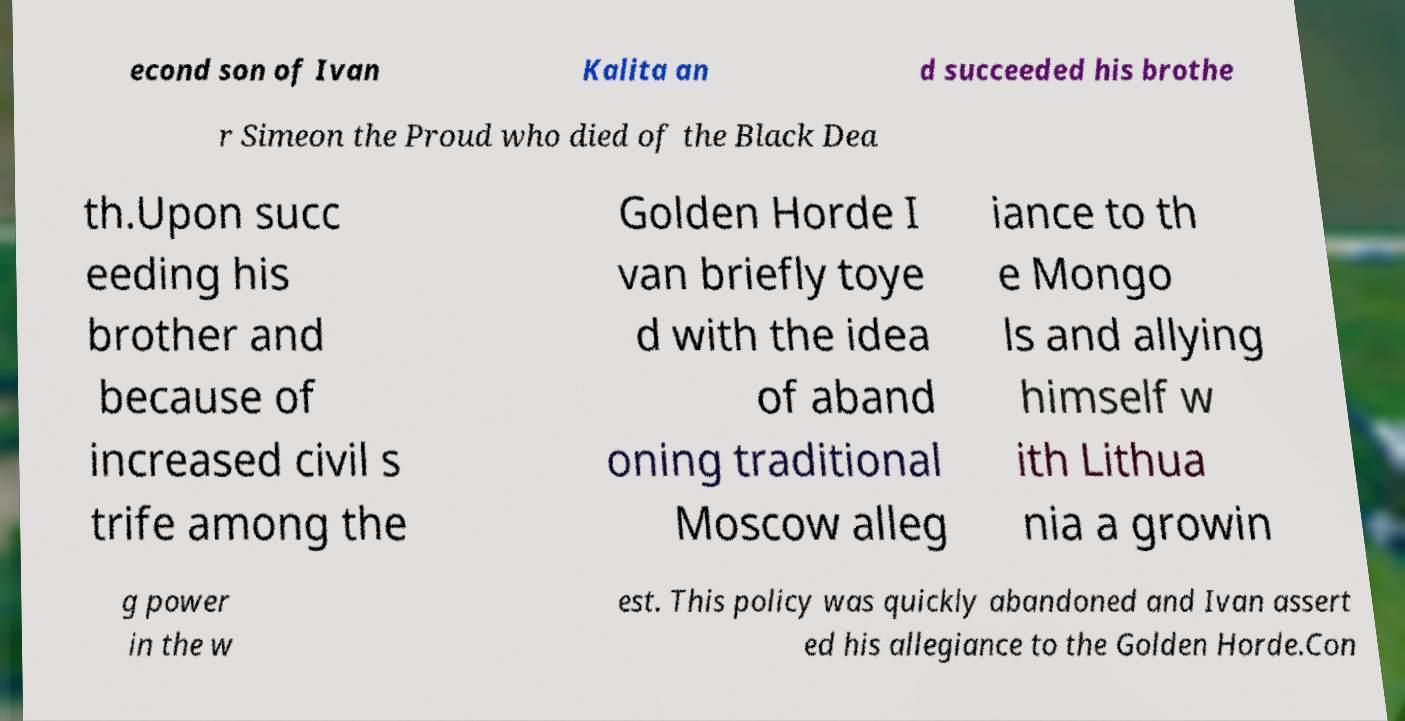Can you accurately transcribe the text from the provided image for me? econd son of Ivan Kalita an d succeeded his brothe r Simeon the Proud who died of the Black Dea th.Upon succ eeding his brother and because of increased civil s trife among the Golden Horde I van briefly toye d with the idea of aband oning traditional Moscow alleg iance to th e Mongo ls and allying himself w ith Lithua nia a growin g power in the w est. This policy was quickly abandoned and Ivan assert ed his allegiance to the Golden Horde.Con 